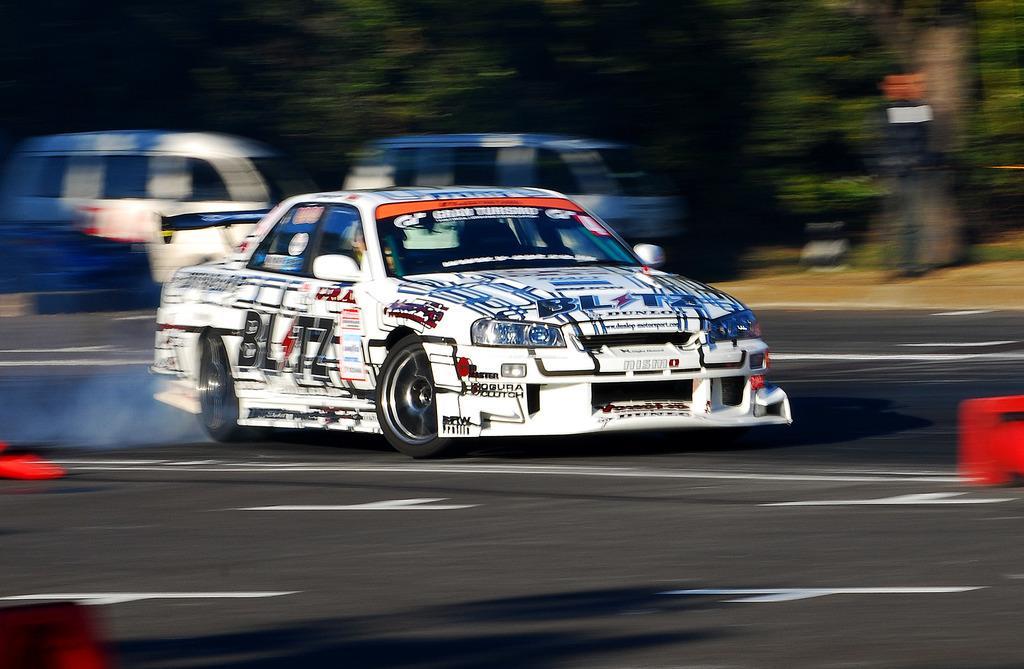In one or two sentences, can you explain what this image depicts? In this image we can see motor vehicles on the road, person standing on the ground and trees. 